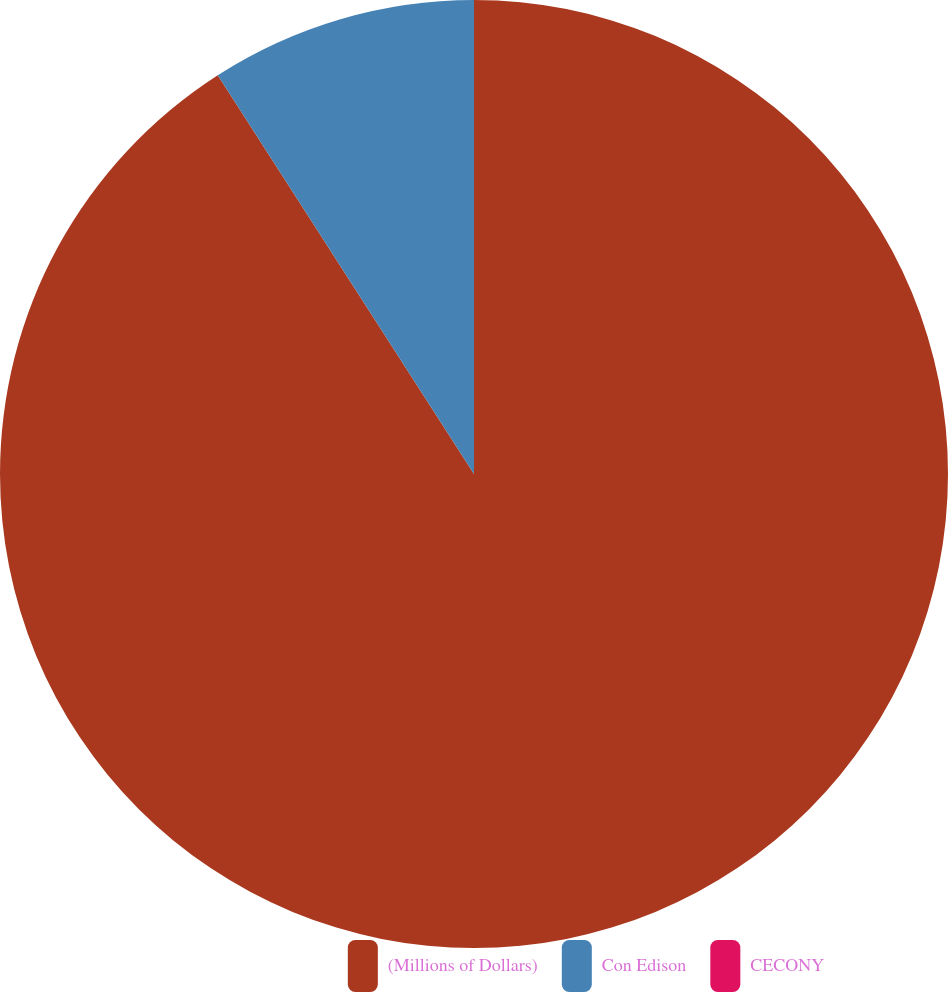Convert chart. <chart><loc_0><loc_0><loc_500><loc_500><pie_chart><fcel>(Millions of Dollars)<fcel>Con Edison<fcel>CECONY<nl><fcel>90.91%<fcel>9.09%<fcel>0.0%<nl></chart> 